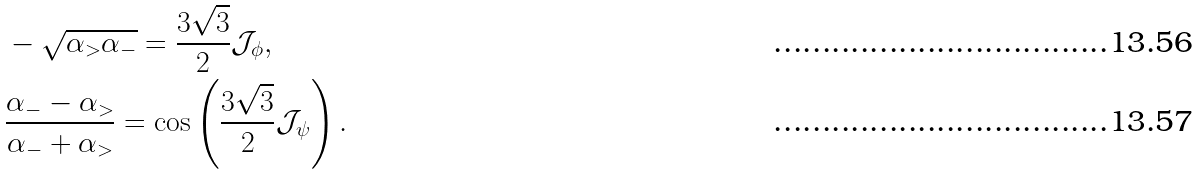Convert formula to latex. <formula><loc_0><loc_0><loc_500><loc_500>& - \sqrt { \alpha _ { > } \alpha _ { - } } = \frac { 3 \sqrt { 3 } } { 2 } \mathcal { J } _ { \phi } , \\ & \frac { \alpha _ { - } - \alpha _ { > } } { \alpha _ { - } + \alpha _ { > } } = \cos \left ( \frac { 3 \sqrt { 3 } } { 2 } \mathcal { J } _ { \psi } \right ) .</formula> 